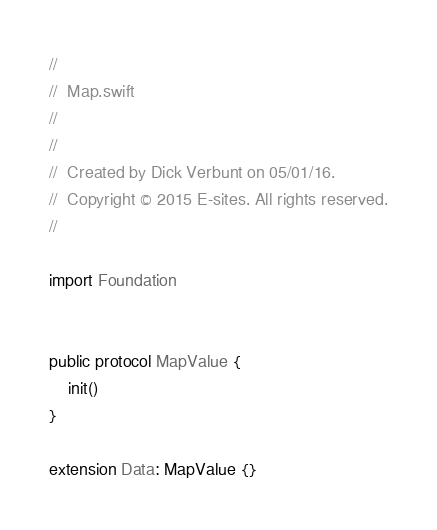<code> <loc_0><loc_0><loc_500><loc_500><_Swift_>//
//  Map.swift
//
//
//  Created by Dick Verbunt on 05/01/16.
//  Copyright © 2015 E-sites. All rights reserved.
//

import Foundation


public protocol MapValue {
    init()
}

extension Data: MapValue {}</code> 